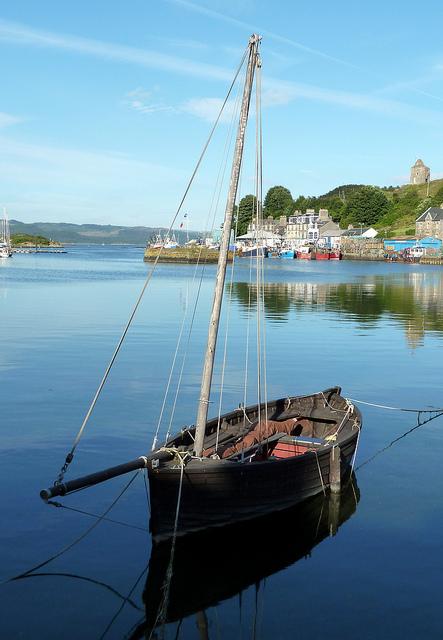What object is floating on the water?
Short answer required. Boat. How tall are the waves?
Quick response, please. Small. Are there sails on the boat?
Quick response, please. No. Are any of these boats powered by gas engines?
Short answer required. No. What color is the boat in the foreground?
Be succinct. Black. 